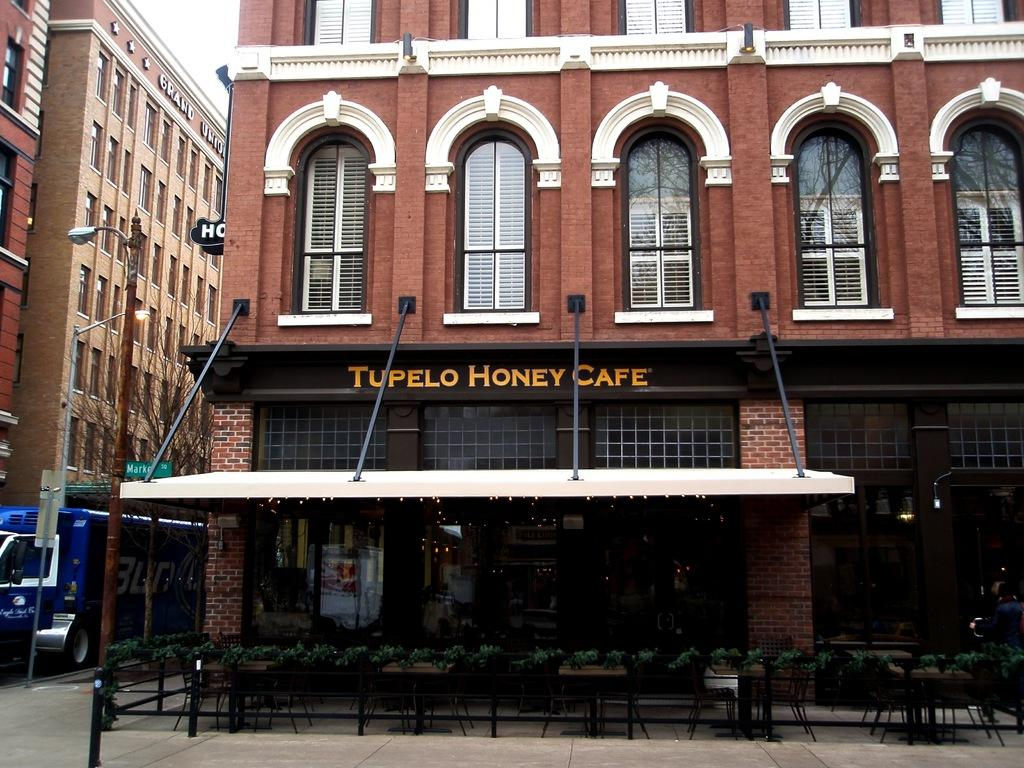What type of furniture is present in the image? There are chairs and tables in the image. What can be used for sitting or placing objects in the image? Chairs and tables can be used for sitting or placing objects in the image. What is visible in the background of the image? Brown-colored buildings and vehicles are visible in the background of the image. What is the color of the sky in the image? The sky appears to be white in color. How many eyes can be seen on the chairs in the image? Chairs do not have eyes, so there are no eyes visible on the chairs in the image. 